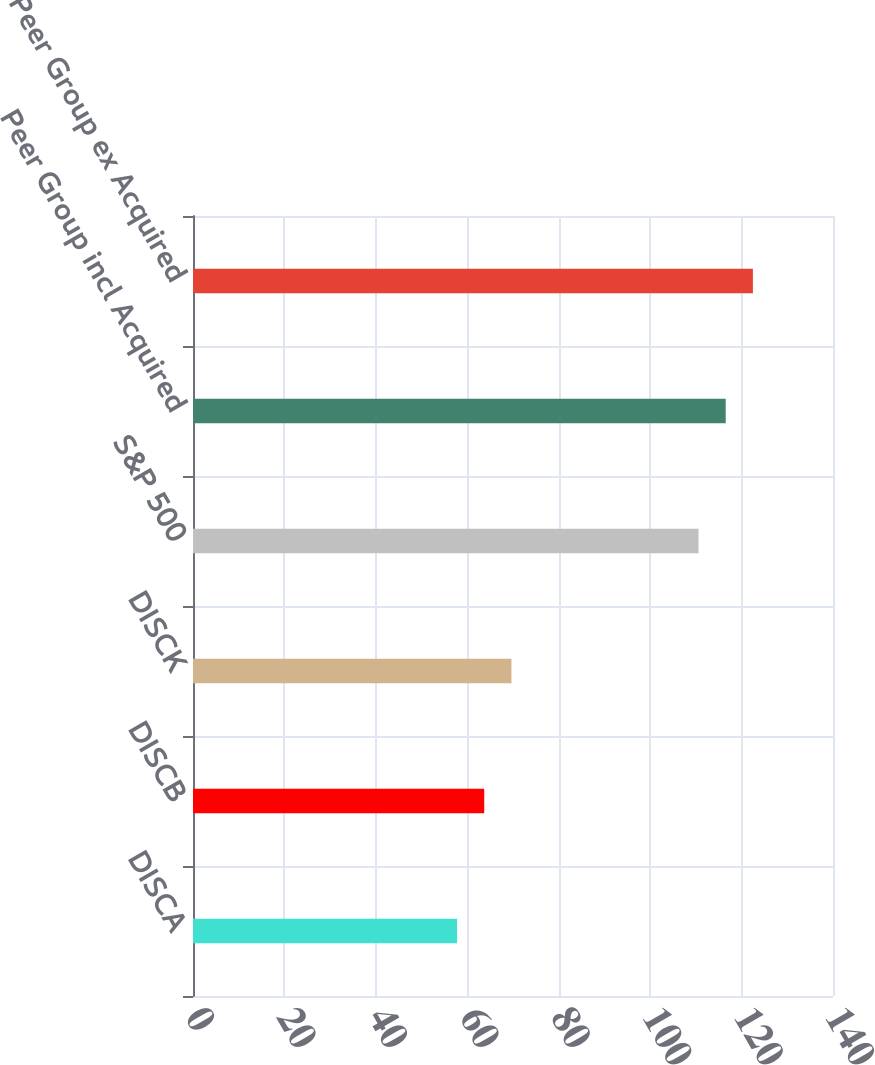Convert chart. <chart><loc_0><loc_0><loc_500><loc_500><bar_chart><fcel>DISCA<fcel>DISCB<fcel>DISCK<fcel>S&P 500<fcel>Peer Group incl Acquired<fcel>Peer Group ex Acquired<nl><fcel>57.76<fcel>63.71<fcel>69.66<fcel>110.58<fcel>116.53<fcel>122.48<nl></chart> 